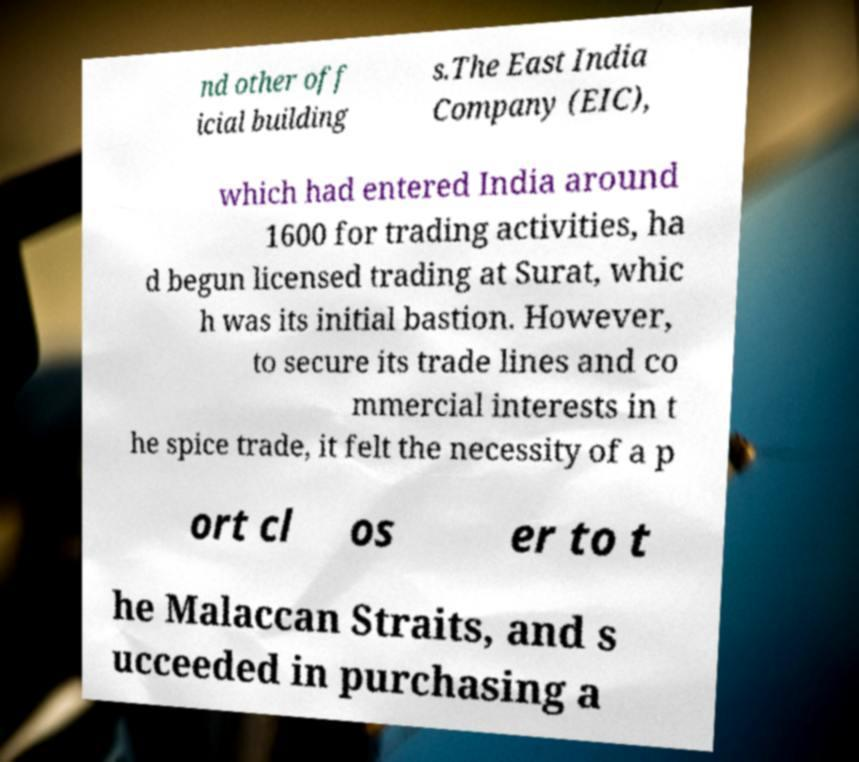Please read and relay the text visible in this image. What does it say? nd other off icial building s.The East India Company (EIC), which had entered India around 1600 for trading activities, ha d begun licensed trading at Surat, whic h was its initial bastion. However, to secure its trade lines and co mmercial interests in t he spice trade, it felt the necessity of a p ort cl os er to t he Malaccan Straits, and s ucceeded in purchasing a 